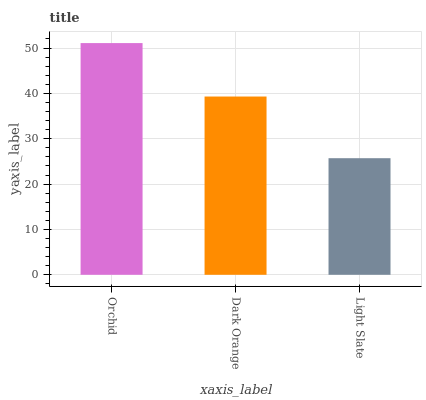Is Light Slate the minimum?
Answer yes or no. Yes. Is Orchid the maximum?
Answer yes or no. Yes. Is Dark Orange the minimum?
Answer yes or no. No. Is Dark Orange the maximum?
Answer yes or no. No. Is Orchid greater than Dark Orange?
Answer yes or no. Yes. Is Dark Orange less than Orchid?
Answer yes or no. Yes. Is Dark Orange greater than Orchid?
Answer yes or no. No. Is Orchid less than Dark Orange?
Answer yes or no. No. Is Dark Orange the high median?
Answer yes or no. Yes. Is Dark Orange the low median?
Answer yes or no. Yes. Is Orchid the high median?
Answer yes or no. No. Is Orchid the low median?
Answer yes or no. No. 